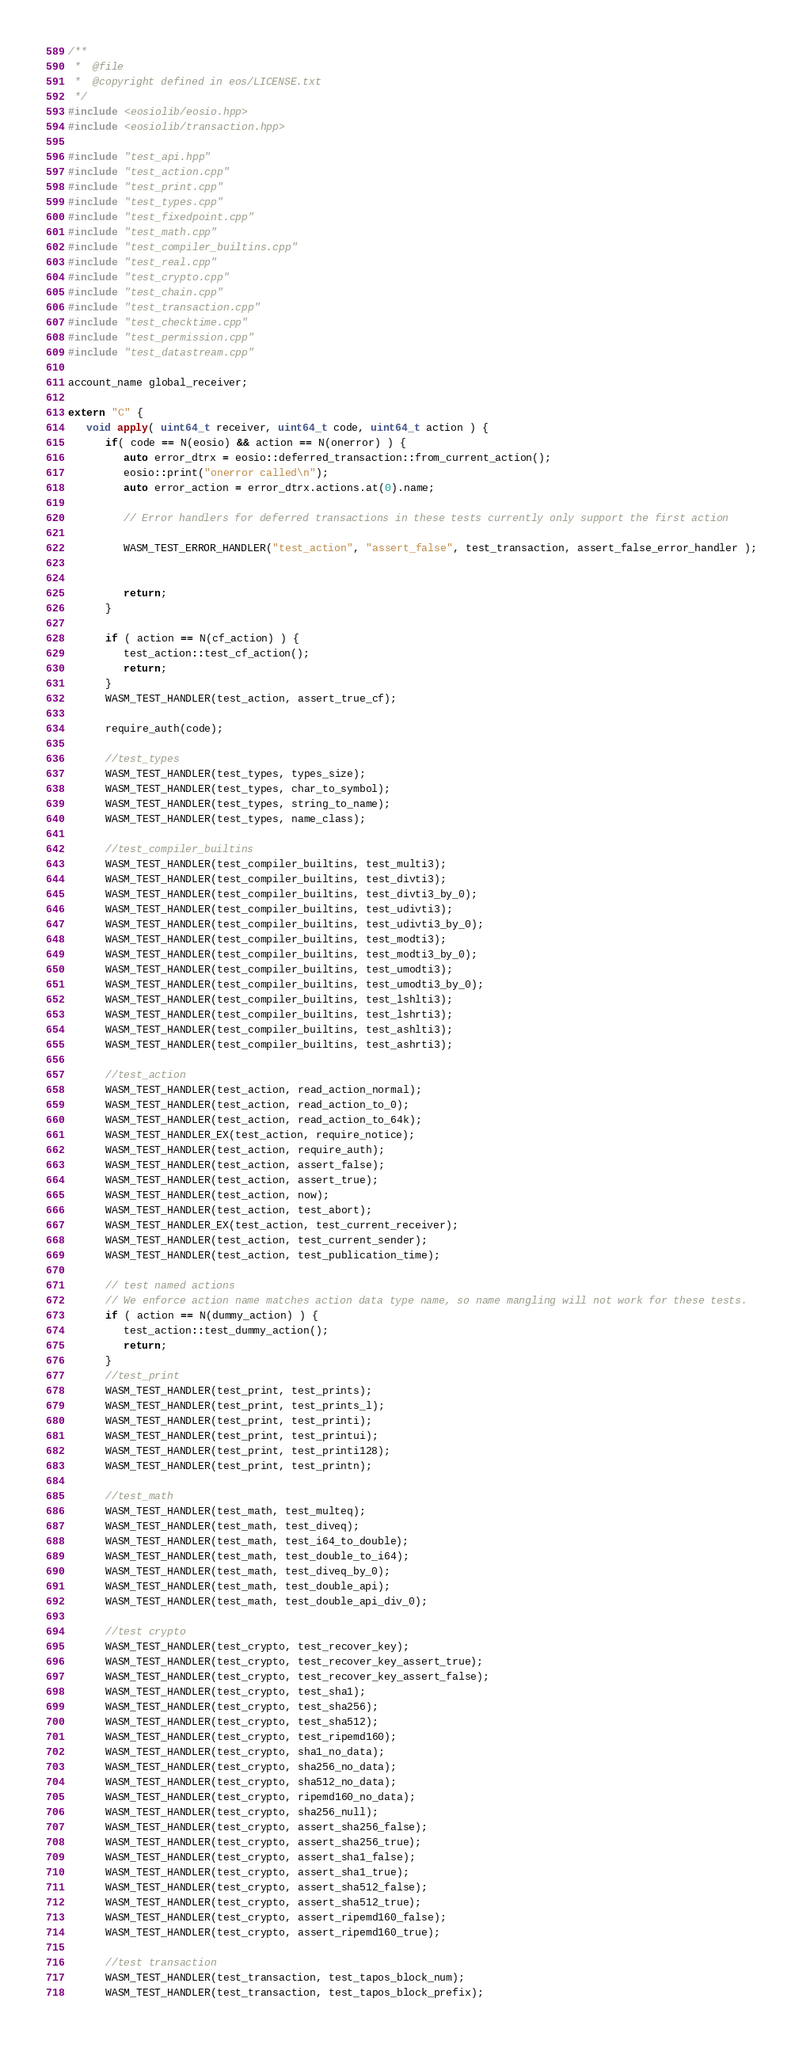Convert code to text. <code><loc_0><loc_0><loc_500><loc_500><_C++_>/**
 *  @file
 *  @copyright defined in eos/LICENSE.txt
 */
#include <eosiolib/eosio.hpp>
#include <eosiolib/transaction.hpp>

#include "test_api.hpp"
#include "test_action.cpp"
#include "test_print.cpp"
#include "test_types.cpp"
#include "test_fixedpoint.cpp"
#include "test_math.cpp"
#include "test_compiler_builtins.cpp"
#include "test_real.cpp"
#include "test_crypto.cpp"
#include "test_chain.cpp"
#include "test_transaction.cpp"
#include "test_checktime.cpp"
#include "test_permission.cpp"
#include "test_datastream.cpp"

account_name global_receiver;

extern "C" {
   void apply( uint64_t receiver, uint64_t code, uint64_t action ) {
      if( code == N(eosio) && action == N(onerror) ) {
         auto error_dtrx = eosio::deferred_transaction::from_current_action();
         eosio::print("onerror called\n");
         auto error_action = error_dtrx.actions.at(0).name;

         // Error handlers for deferred transactions in these tests currently only support the first action

         WASM_TEST_ERROR_HANDLER("test_action", "assert_false", test_transaction, assert_false_error_handler );


         return;
      }

      if ( action == N(cf_action) ) {
         test_action::test_cf_action();
         return;
      }
      WASM_TEST_HANDLER(test_action, assert_true_cf);

      require_auth(code);

      //test_types
      WASM_TEST_HANDLER(test_types, types_size);
      WASM_TEST_HANDLER(test_types, char_to_symbol);
      WASM_TEST_HANDLER(test_types, string_to_name);
      WASM_TEST_HANDLER(test_types, name_class);

      //test_compiler_builtins
      WASM_TEST_HANDLER(test_compiler_builtins, test_multi3);
      WASM_TEST_HANDLER(test_compiler_builtins, test_divti3);
      WASM_TEST_HANDLER(test_compiler_builtins, test_divti3_by_0);
      WASM_TEST_HANDLER(test_compiler_builtins, test_udivti3);
      WASM_TEST_HANDLER(test_compiler_builtins, test_udivti3_by_0);
      WASM_TEST_HANDLER(test_compiler_builtins, test_modti3);
      WASM_TEST_HANDLER(test_compiler_builtins, test_modti3_by_0);
      WASM_TEST_HANDLER(test_compiler_builtins, test_umodti3);
      WASM_TEST_HANDLER(test_compiler_builtins, test_umodti3_by_0);
      WASM_TEST_HANDLER(test_compiler_builtins, test_lshlti3);
      WASM_TEST_HANDLER(test_compiler_builtins, test_lshrti3);
      WASM_TEST_HANDLER(test_compiler_builtins, test_ashlti3);
      WASM_TEST_HANDLER(test_compiler_builtins, test_ashrti3);

      //test_action
      WASM_TEST_HANDLER(test_action, read_action_normal);
      WASM_TEST_HANDLER(test_action, read_action_to_0);
      WASM_TEST_HANDLER(test_action, read_action_to_64k);
      WASM_TEST_HANDLER_EX(test_action, require_notice);
      WASM_TEST_HANDLER(test_action, require_auth);
      WASM_TEST_HANDLER(test_action, assert_false);
      WASM_TEST_HANDLER(test_action, assert_true);
      WASM_TEST_HANDLER(test_action, now);
      WASM_TEST_HANDLER(test_action, test_abort);
      WASM_TEST_HANDLER_EX(test_action, test_current_receiver);
      WASM_TEST_HANDLER(test_action, test_current_sender);
      WASM_TEST_HANDLER(test_action, test_publication_time);

      // test named actions
      // We enforce action name matches action data type name, so name mangling will not work for these tests.
      if ( action == N(dummy_action) ) {
         test_action::test_dummy_action();
         return;
      }
      //test_print
      WASM_TEST_HANDLER(test_print, test_prints);
      WASM_TEST_HANDLER(test_print, test_prints_l);
      WASM_TEST_HANDLER(test_print, test_printi);
      WASM_TEST_HANDLER(test_print, test_printui);
      WASM_TEST_HANDLER(test_print, test_printi128);
      WASM_TEST_HANDLER(test_print, test_printn);

      //test_math
      WASM_TEST_HANDLER(test_math, test_multeq);
      WASM_TEST_HANDLER(test_math, test_diveq);
      WASM_TEST_HANDLER(test_math, test_i64_to_double);
      WASM_TEST_HANDLER(test_math, test_double_to_i64);
      WASM_TEST_HANDLER(test_math, test_diveq_by_0);
      WASM_TEST_HANDLER(test_math, test_double_api);
      WASM_TEST_HANDLER(test_math, test_double_api_div_0);

      //test crypto
      WASM_TEST_HANDLER(test_crypto, test_recover_key);
      WASM_TEST_HANDLER(test_crypto, test_recover_key_assert_true);
      WASM_TEST_HANDLER(test_crypto, test_recover_key_assert_false);
      WASM_TEST_HANDLER(test_crypto, test_sha1);
      WASM_TEST_HANDLER(test_crypto, test_sha256);
      WASM_TEST_HANDLER(test_crypto, test_sha512);
      WASM_TEST_HANDLER(test_crypto, test_ripemd160);
      WASM_TEST_HANDLER(test_crypto, sha1_no_data);
      WASM_TEST_HANDLER(test_crypto, sha256_no_data);
      WASM_TEST_HANDLER(test_crypto, sha512_no_data);
      WASM_TEST_HANDLER(test_crypto, ripemd160_no_data);
      WASM_TEST_HANDLER(test_crypto, sha256_null);
      WASM_TEST_HANDLER(test_crypto, assert_sha256_false);
      WASM_TEST_HANDLER(test_crypto, assert_sha256_true);
      WASM_TEST_HANDLER(test_crypto, assert_sha1_false);
      WASM_TEST_HANDLER(test_crypto, assert_sha1_true);
      WASM_TEST_HANDLER(test_crypto, assert_sha512_false);
      WASM_TEST_HANDLER(test_crypto, assert_sha512_true);
      WASM_TEST_HANDLER(test_crypto, assert_ripemd160_false);
      WASM_TEST_HANDLER(test_crypto, assert_ripemd160_true);

      //test transaction
      WASM_TEST_HANDLER(test_transaction, test_tapos_block_num);
      WASM_TEST_HANDLER(test_transaction, test_tapos_block_prefix);</code> 